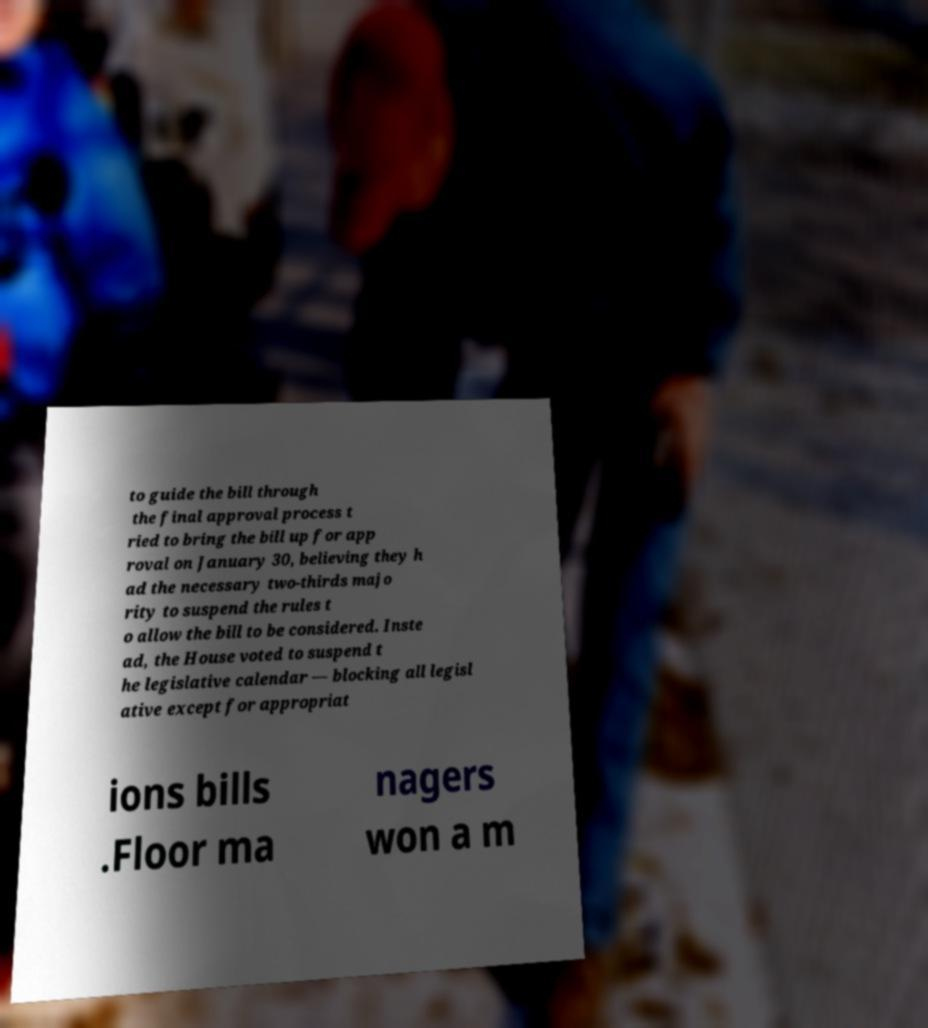Could you extract and type out the text from this image? to guide the bill through the final approval process t ried to bring the bill up for app roval on January 30, believing they h ad the necessary two-thirds majo rity to suspend the rules t o allow the bill to be considered. Inste ad, the House voted to suspend t he legislative calendar — blocking all legisl ative except for appropriat ions bills .Floor ma nagers won a m 